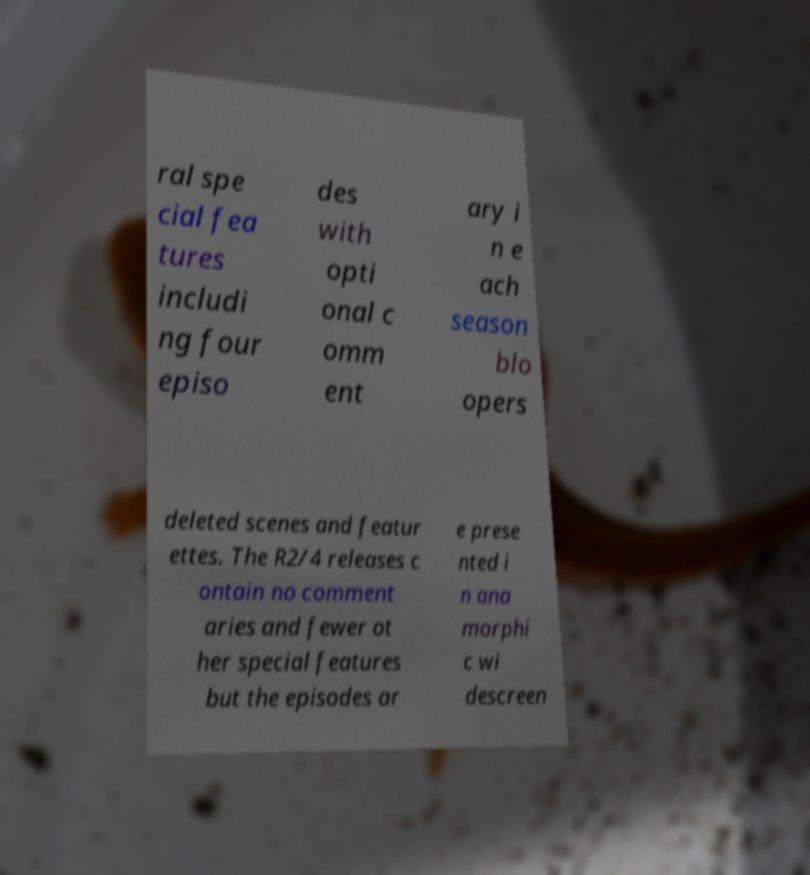Can you accurately transcribe the text from the provided image for me? ral spe cial fea tures includi ng four episo des with opti onal c omm ent ary i n e ach season blo opers deleted scenes and featur ettes. The R2/4 releases c ontain no comment aries and fewer ot her special features but the episodes ar e prese nted i n ana morphi c wi descreen 